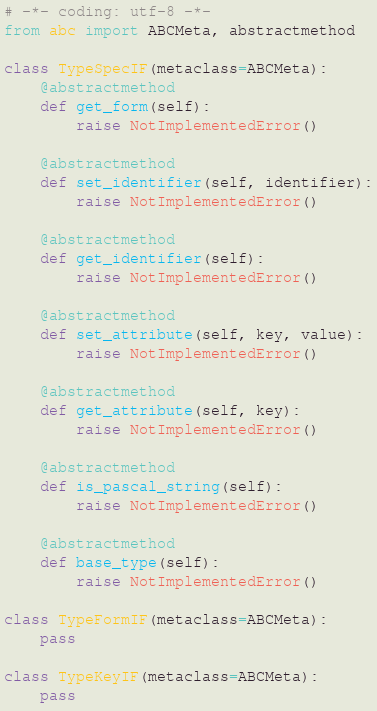<code> <loc_0><loc_0><loc_500><loc_500><_Python_># -*- coding: utf-8 -*-
from abc import ABCMeta, abstractmethod

class TypeSpecIF(metaclass=ABCMeta):
    @abstractmethod
    def get_form(self):
        raise NotImplementedError()

    @abstractmethod
    def set_identifier(self, identifier):
        raise NotImplementedError()

    @abstractmethod
    def get_identifier(self):
        raise NotImplementedError()

    @abstractmethod
    def set_attribute(self, key, value):
        raise NotImplementedError()

    @abstractmethod
    def get_attribute(self, key):
        raise NotImplementedError()

    @abstractmethod
    def is_pascal_string(self):
        raise NotImplementedError()

    @abstractmethod
    def base_type(self):
        raise NotImplementedError()

class TypeFormIF(metaclass=ABCMeta):
    pass

class TypeKeyIF(metaclass=ABCMeta):
    pass

</code> 